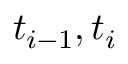<formula> <loc_0><loc_0><loc_500><loc_500>t _ { i - 1 } , t _ { i }</formula> 